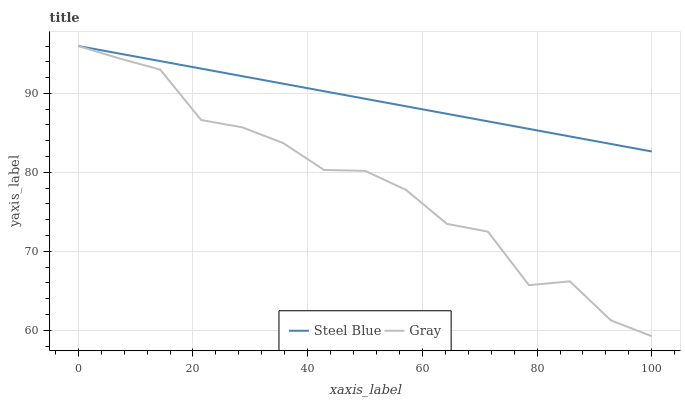Does Gray have the minimum area under the curve?
Answer yes or no. Yes. Does Steel Blue have the maximum area under the curve?
Answer yes or no. Yes. Does Steel Blue have the minimum area under the curve?
Answer yes or no. No. Is Steel Blue the smoothest?
Answer yes or no. Yes. Is Gray the roughest?
Answer yes or no. Yes. Is Steel Blue the roughest?
Answer yes or no. No. Does Gray have the lowest value?
Answer yes or no. Yes. Does Steel Blue have the lowest value?
Answer yes or no. No. Does Steel Blue have the highest value?
Answer yes or no. Yes. Does Gray intersect Steel Blue?
Answer yes or no. Yes. Is Gray less than Steel Blue?
Answer yes or no. No. Is Gray greater than Steel Blue?
Answer yes or no. No. 